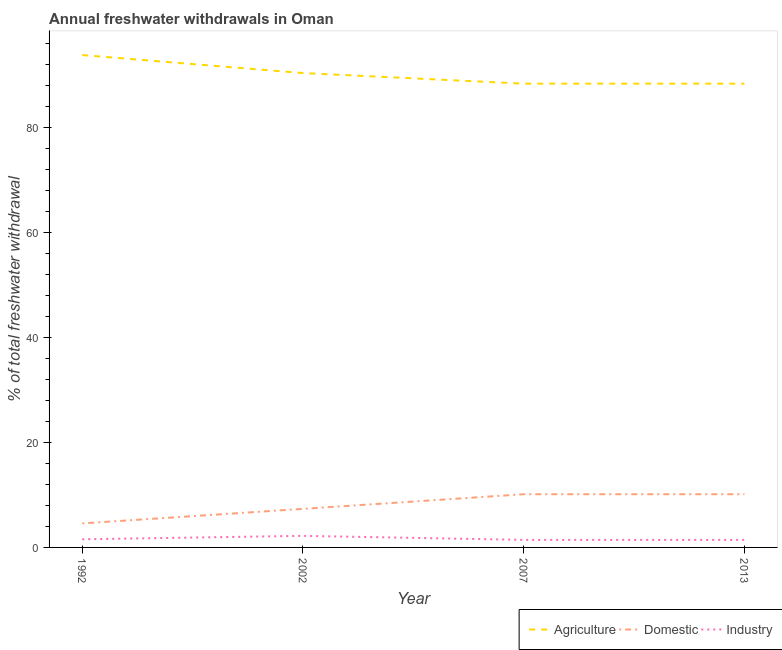How many different coloured lines are there?
Your response must be concise. 3. Does the line corresponding to percentage of freshwater withdrawal for agriculture intersect with the line corresponding to percentage of freshwater withdrawal for industry?
Give a very brief answer. No. Is the number of lines equal to the number of legend labels?
Offer a terse response. Yes. What is the percentage of freshwater withdrawal for industry in 2007?
Keep it short and to the point. 1.44. Across all years, what is the maximum percentage of freshwater withdrawal for agriculture?
Your response must be concise. 93.87. Across all years, what is the minimum percentage of freshwater withdrawal for industry?
Offer a terse response. 1.44. In which year was the percentage of freshwater withdrawal for industry minimum?
Provide a short and direct response. 2007. What is the total percentage of freshwater withdrawal for industry in the graph?
Provide a succinct answer. 6.64. What is the difference between the percentage of freshwater withdrawal for domestic purposes in 2013 and the percentage of freshwater withdrawal for agriculture in 2002?
Provide a short and direct response. -80.3. What is the average percentage of freshwater withdrawal for agriculture per year?
Give a very brief answer. 90.29. In the year 1992, what is the difference between the percentage of freshwater withdrawal for agriculture and percentage of freshwater withdrawal for industry?
Provide a succinct answer. 92.32. What is the ratio of the percentage of freshwater withdrawal for agriculture in 2002 to that in 2013?
Keep it short and to the point. 1.02. What is the difference between the highest and the lowest percentage of freshwater withdrawal for agriculture?
Give a very brief answer. 5.45. In how many years, is the percentage of freshwater withdrawal for agriculture greater than the average percentage of freshwater withdrawal for agriculture taken over all years?
Make the answer very short. 2. Does the percentage of freshwater withdrawal for industry monotonically increase over the years?
Your response must be concise. No. Is the percentage of freshwater withdrawal for domestic purposes strictly greater than the percentage of freshwater withdrawal for agriculture over the years?
Make the answer very short. No. How many lines are there?
Make the answer very short. 3. What is the difference between two consecutive major ticks on the Y-axis?
Ensure brevity in your answer.  20. Are the values on the major ticks of Y-axis written in scientific E-notation?
Your answer should be compact. No. Does the graph contain any zero values?
Your answer should be very brief. No. How many legend labels are there?
Keep it short and to the point. 3. What is the title of the graph?
Offer a very short reply. Annual freshwater withdrawals in Oman. Does "Transport services" appear as one of the legend labels in the graph?
Make the answer very short. No. What is the label or title of the X-axis?
Ensure brevity in your answer.  Year. What is the label or title of the Y-axis?
Provide a short and direct response. % of total freshwater withdrawal. What is the % of total freshwater withdrawal in Agriculture in 1992?
Your response must be concise. 93.87. What is the % of total freshwater withdrawal of Domestic in 1992?
Your answer should be very brief. 4.58. What is the % of total freshwater withdrawal in Industry in 1992?
Keep it short and to the point. 1.55. What is the % of total freshwater withdrawal of Agriculture in 2002?
Keep it short and to the point. 90.44. What is the % of total freshwater withdrawal in Domestic in 2002?
Offer a terse response. 7.35. What is the % of total freshwater withdrawal of Industry in 2002?
Your response must be concise. 2.21. What is the % of total freshwater withdrawal in Agriculture in 2007?
Provide a succinct answer. 88.42. What is the % of total freshwater withdrawal in Domestic in 2007?
Ensure brevity in your answer.  10.14. What is the % of total freshwater withdrawal in Industry in 2007?
Offer a very short reply. 1.44. What is the % of total freshwater withdrawal in Agriculture in 2013?
Make the answer very short. 88.42. What is the % of total freshwater withdrawal in Domestic in 2013?
Offer a terse response. 10.14. What is the % of total freshwater withdrawal of Industry in 2013?
Ensure brevity in your answer.  1.44. Across all years, what is the maximum % of total freshwater withdrawal in Agriculture?
Your answer should be compact. 93.87. Across all years, what is the maximum % of total freshwater withdrawal of Domestic?
Your answer should be compact. 10.14. Across all years, what is the maximum % of total freshwater withdrawal in Industry?
Give a very brief answer. 2.21. Across all years, what is the minimum % of total freshwater withdrawal in Agriculture?
Offer a terse response. 88.42. Across all years, what is the minimum % of total freshwater withdrawal of Domestic?
Your answer should be very brief. 4.58. Across all years, what is the minimum % of total freshwater withdrawal of Industry?
Your answer should be very brief. 1.44. What is the total % of total freshwater withdrawal in Agriculture in the graph?
Provide a succinct answer. 361.15. What is the total % of total freshwater withdrawal in Domestic in the graph?
Your response must be concise. 32.21. What is the total % of total freshwater withdrawal in Industry in the graph?
Keep it short and to the point. 6.64. What is the difference between the % of total freshwater withdrawal of Agriculture in 1992 and that in 2002?
Give a very brief answer. 3.43. What is the difference between the % of total freshwater withdrawal of Domestic in 1992 and that in 2002?
Keep it short and to the point. -2.77. What is the difference between the % of total freshwater withdrawal of Industry in 1992 and that in 2002?
Ensure brevity in your answer.  -0.65. What is the difference between the % of total freshwater withdrawal of Agriculture in 1992 and that in 2007?
Your response must be concise. 5.45. What is the difference between the % of total freshwater withdrawal of Domestic in 1992 and that in 2007?
Your response must be concise. -5.56. What is the difference between the % of total freshwater withdrawal of Industry in 1992 and that in 2007?
Provide a succinct answer. 0.12. What is the difference between the % of total freshwater withdrawal in Agriculture in 1992 and that in 2013?
Make the answer very short. 5.45. What is the difference between the % of total freshwater withdrawal of Domestic in 1992 and that in 2013?
Provide a succinct answer. -5.56. What is the difference between the % of total freshwater withdrawal in Industry in 1992 and that in 2013?
Your answer should be very brief. 0.12. What is the difference between the % of total freshwater withdrawal of Agriculture in 2002 and that in 2007?
Offer a very short reply. 2.02. What is the difference between the % of total freshwater withdrawal in Domestic in 2002 and that in 2007?
Keep it short and to the point. -2.79. What is the difference between the % of total freshwater withdrawal in Industry in 2002 and that in 2007?
Provide a succinct answer. 0.77. What is the difference between the % of total freshwater withdrawal of Agriculture in 2002 and that in 2013?
Give a very brief answer. 2.02. What is the difference between the % of total freshwater withdrawal of Domestic in 2002 and that in 2013?
Your response must be concise. -2.79. What is the difference between the % of total freshwater withdrawal of Industry in 2002 and that in 2013?
Give a very brief answer. 0.77. What is the difference between the % of total freshwater withdrawal in Agriculture in 2007 and that in 2013?
Offer a very short reply. 0. What is the difference between the % of total freshwater withdrawal in Industry in 2007 and that in 2013?
Offer a terse response. 0. What is the difference between the % of total freshwater withdrawal in Agriculture in 1992 and the % of total freshwater withdrawal in Domestic in 2002?
Offer a terse response. 86.52. What is the difference between the % of total freshwater withdrawal in Agriculture in 1992 and the % of total freshwater withdrawal in Industry in 2002?
Offer a terse response. 91.66. What is the difference between the % of total freshwater withdrawal in Domestic in 1992 and the % of total freshwater withdrawal in Industry in 2002?
Provide a short and direct response. 2.37. What is the difference between the % of total freshwater withdrawal of Agriculture in 1992 and the % of total freshwater withdrawal of Domestic in 2007?
Provide a succinct answer. 83.73. What is the difference between the % of total freshwater withdrawal of Agriculture in 1992 and the % of total freshwater withdrawal of Industry in 2007?
Keep it short and to the point. 92.43. What is the difference between the % of total freshwater withdrawal in Domestic in 1992 and the % of total freshwater withdrawal in Industry in 2007?
Offer a terse response. 3.14. What is the difference between the % of total freshwater withdrawal in Agriculture in 1992 and the % of total freshwater withdrawal in Domestic in 2013?
Ensure brevity in your answer.  83.73. What is the difference between the % of total freshwater withdrawal in Agriculture in 1992 and the % of total freshwater withdrawal in Industry in 2013?
Offer a terse response. 92.43. What is the difference between the % of total freshwater withdrawal of Domestic in 1992 and the % of total freshwater withdrawal of Industry in 2013?
Make the answer very short. 3.14. What is the difference between the % of total freshwater withdrawal in Agriculture in 2002 and the % of total freshwater withdrawal in Domestic in 2007?
Give a very brief answer. 80.3. What is the difference between the % of total freshwater withdrawal of Agriculture in 2002 and the % of total freshwater withdrawal of Industry in 2007?
Offer a terse response. 89. What is the difference between the % of total freshwater withdrawal of Domestic in 2002 and the % of total freshwater withdrawal of Industry in 2007?
Your answer should be compact. 5.92. What is the difference between the % of total freshwater withdrawal in Agriculture in 2002 and the % of total freshwater withdrawal in Domestic in 2013?
Your response must be concise. 80.3. What is the difference between the % of total freshwater withdrawal of Agriculture in 2002 and the % of total freshwater withdrawal of Industry in 2013?
Give a very brief answer. 89. What is the difference between the % of total freshwater withdrawal in Domestic in 2002 and the % of total freshwater withdrawal in Industry in 2013?
Your answer should be compact. 5.92. What is the difference between the % of total freshwater withdrawal in Agriculture in 2007 and the % of total freshwater withdrawal in Domestic in 2013?
Provide a short and direct response. 78.28. What is the difference between the % of total freshwater withdrawal of Agriculture in 2007 and the % of total freshwater withdrawal of Industry in 2013?
Keep it short and to the point. 86.98. What is the difference between the % of total freshwater withdrawal in Domestic in 2007 and the % of total freshwater withdrawal in Industry in 2013?
Offer a terse response. 8.7. What is the average % of total freshwater withdrawal in Agriculture per year?
Ensure brevity in your answer.  90.29. What is the average % of total freshwater withdrawal of Domestic per year?
Ensure brevity in your answer.  8.05. What is the average % of total freshwater withdrawal in Industry per year?
Offer a very short reply. 1.66. In the year 1992, what is the difference between the % of total freshwater withdrawal of Agriculture and % of total freshwater withdrawal of Domestic?
Your answer should be very brief. 89.29. In the year 1992, what is the difference between the % of total freshwater withdrawal of Agriculture and % of total freshwater withdrawal of Industry?
Provide a succinct answer. 92.32. In the year 1992, what is the difference between the % of total freshwater withdrawal of Domestic and % of total freshwater withdrawal of Industry?
Make the answer very short. 3.02. In the year 2002, what is the difference between the % of total freshwater withdrawal in Agriculture and % of total freshwater withdrawal in Domestic?
Your answer should be compact. 83.09. In the year 2002, what is the difference between the % of total freshwater withdrawal of Agriculture and % of total freshwater withdrawal of Industry?
Offer a very short reply. 88.23. In the year 2002, what is the difference between the % of total freshwater withdrawal of Domestic and % of total freshwater withdrawal of Industry?
Offer a terse response. 5.15. In the year 2007, what is the difference between the % of total freshwater withdrawal of Agriculture and % of total freshwater withdrawal of Domestic?
Your answer should be very brief. 78.28. In the year 2007, what is the difference between the % of total freshwater withdrawal of Agriculture and % of total freshwater withdrawal of Industry?
Provide a short and direct response. 86.98. In the year 2007, what is the difference between the % of total freshwater withdrawal of Domestic and % of total freshwater withdrawal of Industry?
Your response must be concise. 8.7. In the year 2013, what is the difference between the % of total freshwater withdrawal of Agriculture and % of total freshwater withdrawal of Domestic?
Provide a short and direct response. 78.28. In the year 2013, what is the difference between the % of total freshwater withdrawal in Agriculture and % of total freshwater withdrawal in Industry?
Provide a short and direct response. 86.98. In the year 2013, what is the difference between the % of total freshwater withdrawal in Domestic and % of total freshwater withdrawal in Industry?
Provide a succinct answer. 8.7. What is the ratio of the % of total freshwater withdrawal in Agriculture in 1992 to that in 2002?
Your response must be concise. 1.04. What is the ratio of the % of total freshwater withdrawal of Domestic in 1992 to that in 2002?
Your answer should be compact. 0.62. What is the ratio of the % of total freshwater withdrawal in Industry in 1992 to that in 2002?
Offer a terse response. 0.7. What is the ratio of the % of total freshwater withdrawal in Agriculture in 1992 to that in 2007?
Your response must be concise. 1.06. What is the ratio of the % of total freshwater withdrawal of Domestic in 1992 to that in 2007?
Keep it short and to the point. 0.45. What is the ratio of the % of total freshwater withdrawal of Industry in 1992 to that in 2007?
Offer a terse response. 1.08. What is the ratio of the % of total freshwater withdrawal in Agriculture in 1992 to that in 2013?
Ensure brevity in your answer.  1.06. What is the ratio of the % of total freshwater withdrawal of Domestic in 1992 to that in 2013?
Keep it short and to the point. 0.45. What is the ratio of the % of total freshwater withdrawal of Industry in 1992 to that in 2013?
Provide a short and direct response. 1.08. What is the ratio of the % of total freshwater withdrawal in Agriculture in 2002 to that in 2007?
Your response must be concise. 1.02. What is the ratio of the % of total freshwater withdrawal of Domestic in 2002 to that in 2007?
Offer a very short reply. 0.73. What is the ratio of the % of total freshwater withdrawal in Industry in 2002 to that in 2007?
Keep it short and to the point. 1.53. What is the ratio of the % of total freshwater withdrawal of Agriculture in 2002 to that in 2013?
Your answer should be compact. 1.02. What is the ratio of the % of total freshwater withdrawal of Domestic in 2002 to that in 2013?
Offer a terse response. 0.73. What is the ratio of the % of total freshwater withdrawal of Industry in 2002 to that in 2013?
Your answer should be very brief. 1.53. What is the ratio of the % of total freshwater withdrawal in Domestic in 2007 to that in 2013?
Your response must be concise. 1. What is the difference between the highest and the second highest % of total freshwater withdrawal of Agriculture?
Provide a short and direct response. 3.43. What is the difference between the highest and the second highest % of total freshwater withdrawal of Industry?
Your answer should be very brief. 0.65. What is the difference between the highest and the lowest % of total freshwater withdrawal of Agriculture?
Offer a terse response. 5.45. What is the difference between the highest and the lowest % of total freshwater withdrawal of Domestic?
Your answer should be compact. 5.56. What is the difference between the highest and the lowest % of total freshwater withdrawal in Industry?
Your answer should be very brief. 0.77. 